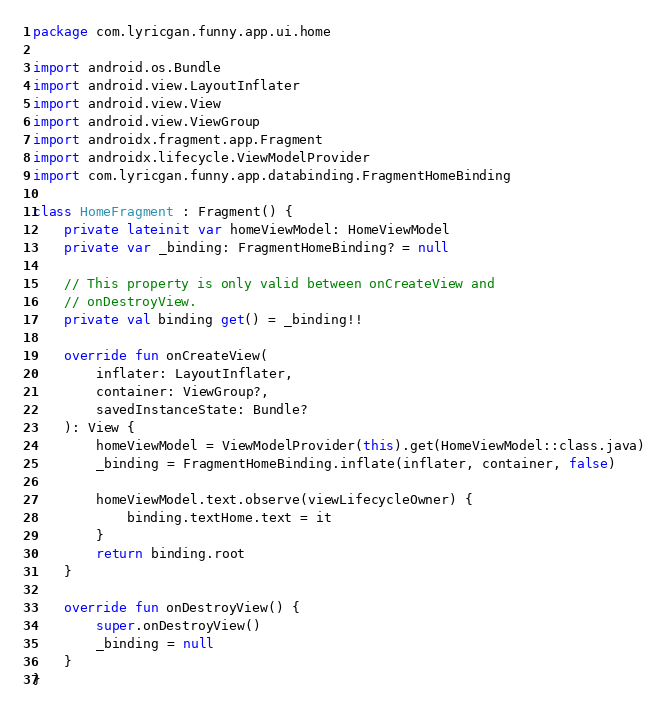Convert code to text. <code><loc_0><loc_0><loc_500><loc_500><_Kotlin_>package com.lyricgan.funny.app.ui.home

import android.os.Bundle
import android.view.LayoutInflater
import android.view.View
import android.view.ViewGroup
import androidx.fragment.app.Fragment
import androidx.lifecycle.ViewModelProvider
import com.lyricgan.funny.app.databinding.FragmentHomeBinding

class HomeFragment : Fragment() {
    private lateinit var homeViewModel: HomeViewModel
    private var _binding: FragmentHomeBinding? = null

    // This property is only valid between onCreateView and
    // onDestroyView.
    private val binding get() = _binding!!

    override fun onCreateView(
        inflater: LayoutInflater,
        container: ViewGroup?,
        savedInstanceState: Bundle?
    ): View {
        homeViewModel = ViewModelProvider(this).get(HomeViewModel::class.java)
        _binding = FragmentHomeBinding.inflate(inflater, container, false)

        homeViewModel.text.observe(viewLifecycleOwner) {
            binding.textHome.text = it
        }
        return binding.root
    }

    override fun onDestroyView() {
        super.onDestroyView()
        _binding = null
    }
}</code> 